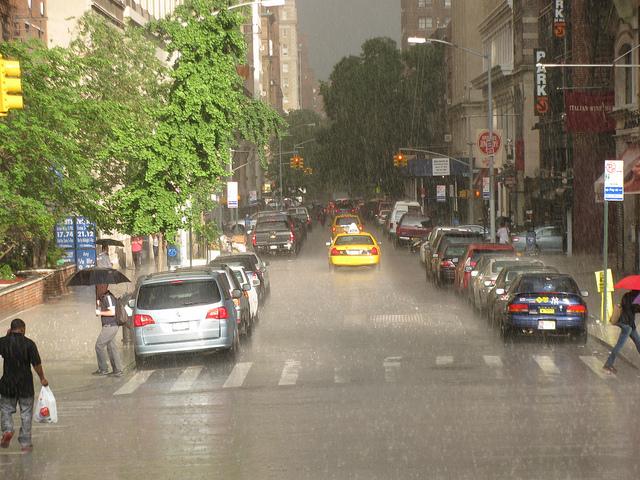Is it night or daytime?
Answer briefly. Daytime. Is it a sunny day?
Short answer required. No. What time of day is it?
Give a very brief answer. Evening. What color is the cab?
Give a very brief answer. Yellow. How many people have an umbrella?
Keep it brief. 2. 